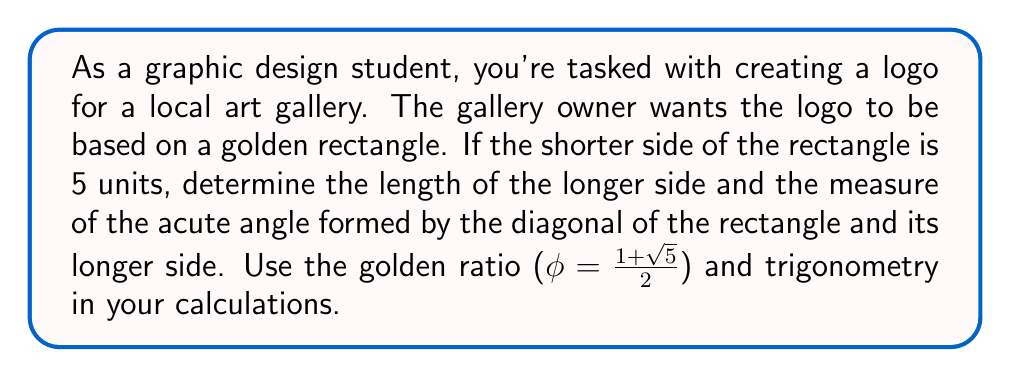Teach me how to tackle this problem. 1. Calculate the length of the longer side:
   The golden ratio is defined as $\phi = \frac{\text{longer side}}{\text{shorter side}}$
   $$\phi = \frac{1+\sqrt{5}}{2} \approx 1.618034$$
   Longer side = $5 \times \phi = 5 \times \frac{1+\sqrt{5}}{2} = \frac{5+5\sqrt{5}}{2} \approx 8.090170$ units

2. Find the length of the diagonal using the Pythagorean theorem:
   $$\text{diagonal}^2 = 5^2 + (\frac{5+5\sqrt{5}}{2})^2$$
   $$\text{diagonal}^2 = 25 + \frac{25+50\sqrt{5}+125}{4} = \frac{100+50\sqrt{5}+125}{4} = \frac{225+50\sqrt{5}}{4}$$
   $$\text{diagonal} = \sqrt{\frac{225+50\sqrt{5}}{4}} = \frac{\sqrt{225+50\sqrt{5}}}{2}$$

3. Calculate the acute angle using the arctangent function:
   $$\theta = \arctan(\frac{\text{shorter side}}{\text{longer side}}) = \arctan(\frac{5}{\frac{5+5\sqrt{5}}{2}})$$
   $$\theta = \arctan(\frac{10}{5+5\sqrt{5}}) = \arctan(\frac{2}{1+\sqrt{5}}) \approx 0.553574 \text{ radians}$$

4. Convert radians to degrees:
   $$\theta \text{ in degrees} = 0.553574 \times \frac{180}{\pi} \approx 31.7175°$$

[asy]
unitsize(1cm);
real phi = (1+sqrt(5))/2;
pair A=(0,0), B=(5*phi,0), C=(5*phi,5), D=(0,5);
draw(A--B--C--D--cycle);
draw(A--C);
label("5", (D+A)/2, W);
label("5φ", (B+A)/2, S);
dot("A", A, SW);
dot("B", B, SE);
dot("C", C, NE);
dot("D", D, NW);
label("θ", B, N);
[/asy]
Answer: Longer side ≈ 8.090170 units, Acute angle θ ≈ 31.7175° 